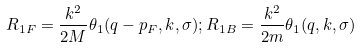<formula> <loc_0><loc_0><loc_500><loc_500>R _ { 1 F } = \frac { k ^ { 2 } } { 2 M } \theta _ { 1 } ( q - p _ { F } , k , \sigma ) ; R _ { 1 B } = \frac { k ^ { 2 } } { 2 m } \theta _ { 1 } ( q , k , \sigma )</formula> 